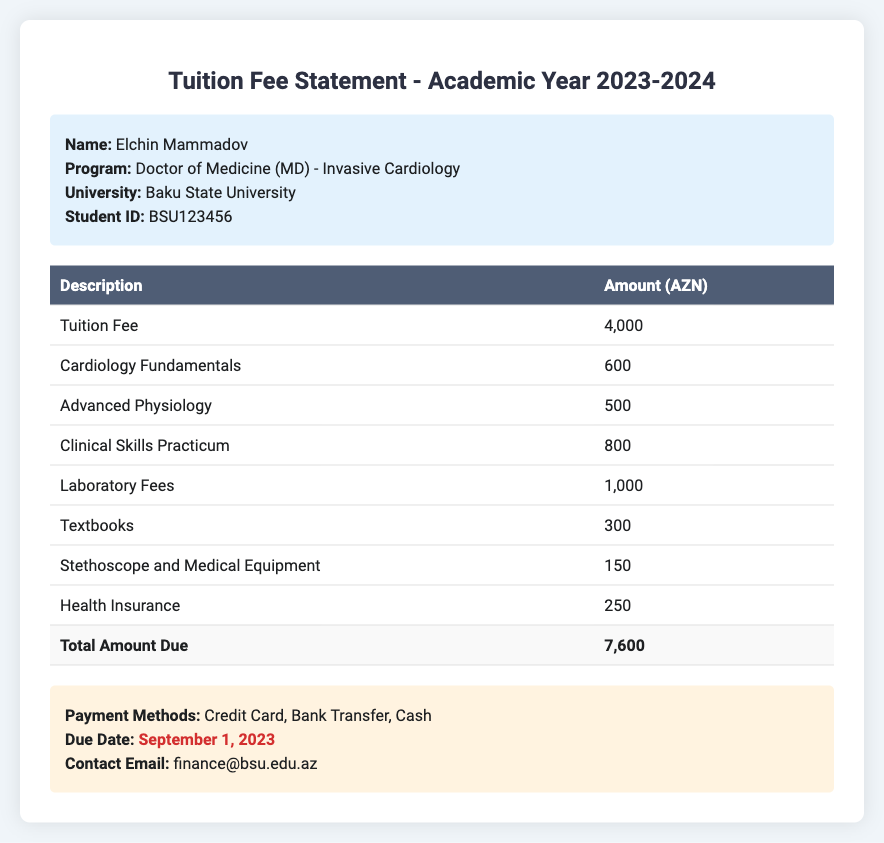What is the name of the student? The student named in the document is Elchin Mammadov.
Answer: Elchin Mammadov What is the total amount due? The total amount due is found in the summary at the end of the fees table.
Answer: 7,600 What is the tuition fee listed? The tuition fee is stated as a separate line item in the fees table.
Answer: 4,000 What is the due date for payment? The due date is highlighted in the payment information section.
Answer: September 1, 2023 Which course has a fee of 800 AZN? The course fee of 800 AZN is mentioned in the context of clinical skills.
Answer: Clinical Skills Practicum What type of program is Elchin Mammadov enrolled in? The document specifies that the student is enrolled in a Doctor of Medicine program.
Answer: Doctor of Medicine (MD) What fee is associated with health insurance? The health insurance fee is explicitly listed in the itemized fees.
Answer: 250 What equipment is mentioned with a fee of 150 AZN? The item with a fee of 150 AZN refers to a necessary piece of medical equipment.
Answer: Stethoscope and Medical Equipment What is one of the available payment methods? The document lists several payment methods for the tuition fees.
Answer: Credit Card 